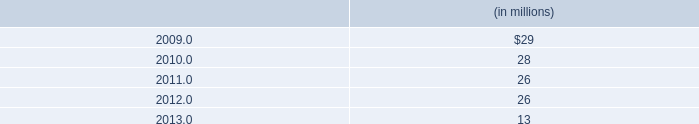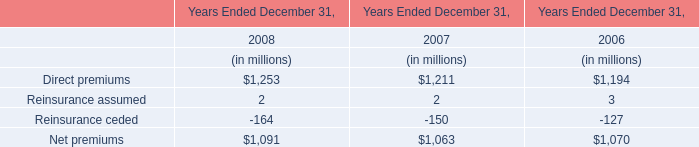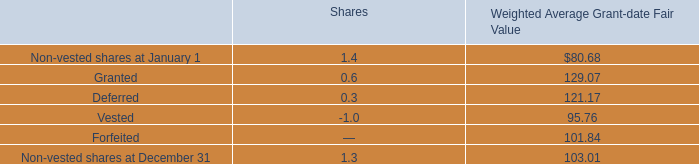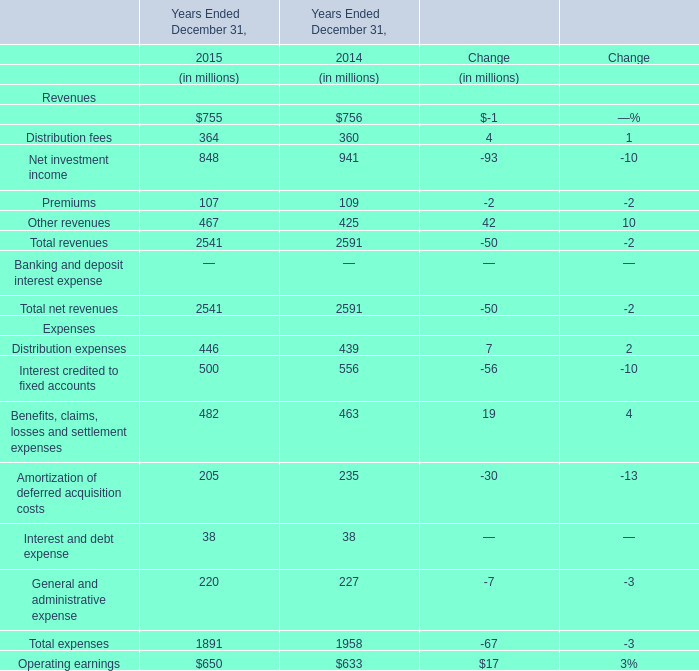what potion of the expected payments related to hurricane katrina and hurricane gustav restoration work and its gas rebuild project will be incurred during 2009? 
Computations: (32 / 113)
Answer: 0.28319. 